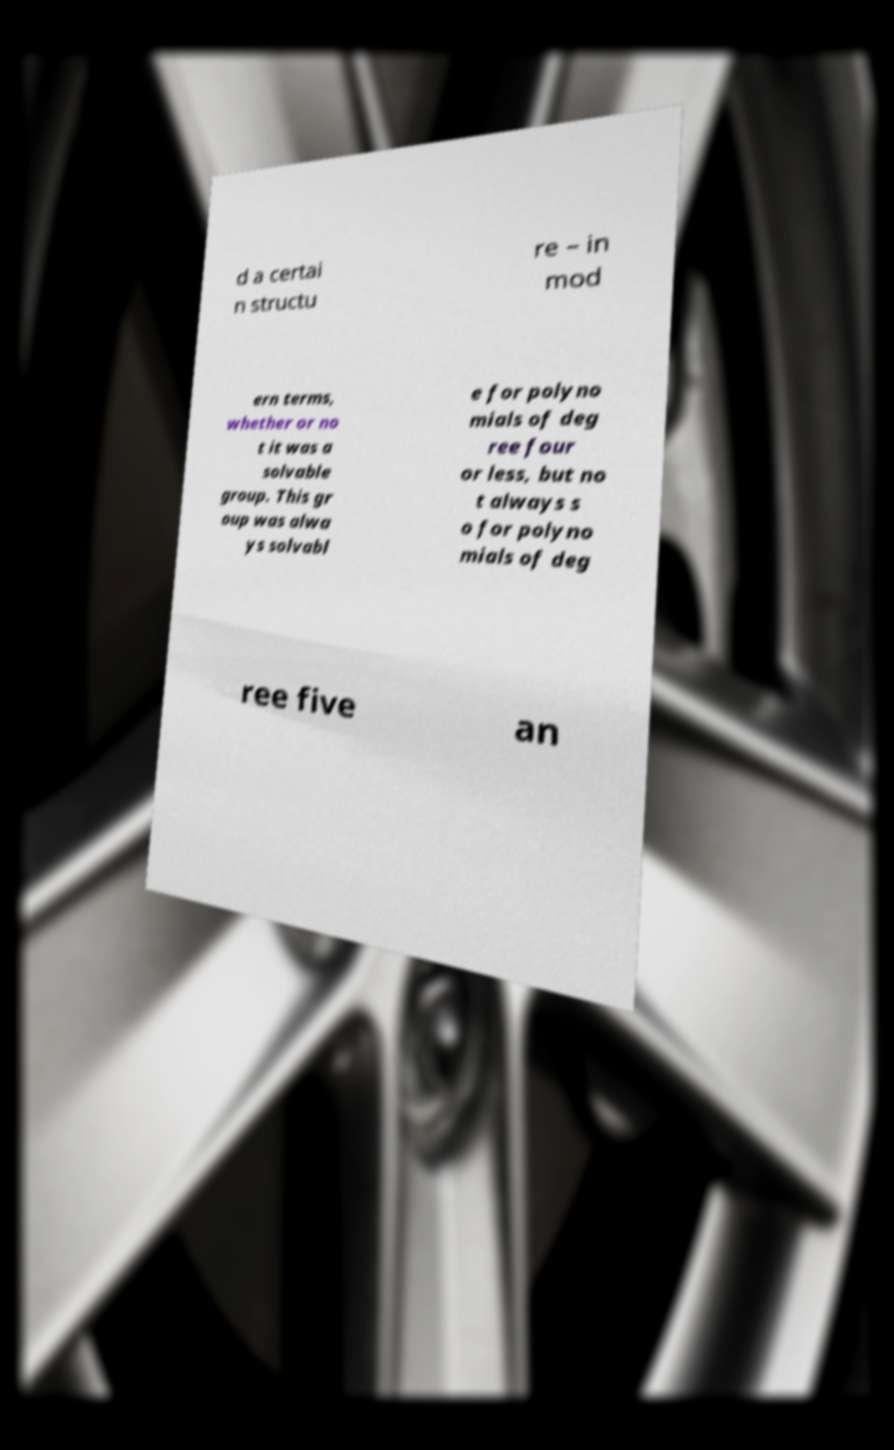I need the written content from this picture converted into text. Can you do that? d a certai n structu re – in mod ern terms, whether or no t it was a solvable group. This gr oup was alwa ys solvabl e for polyno mials of deg ree four or less, but no t always s o for polyno mials of deg ree five an 